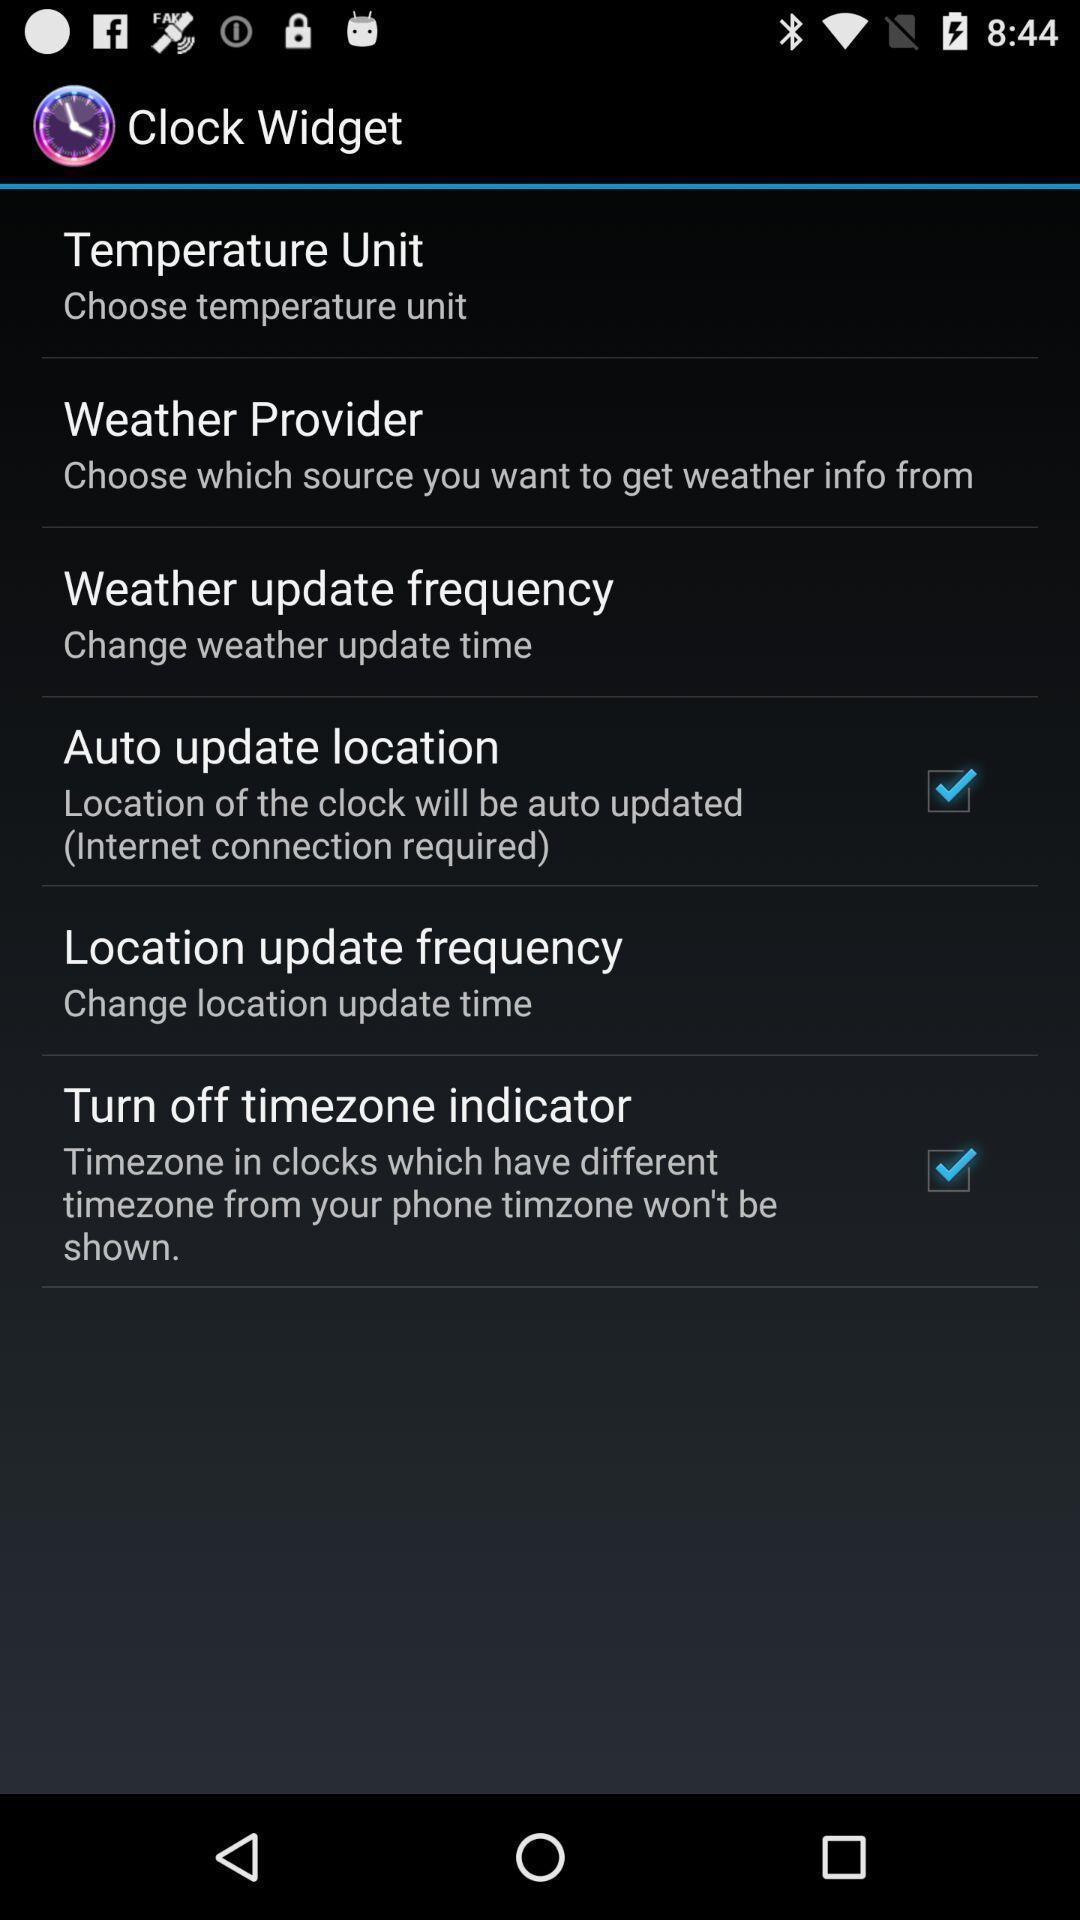Describe this image in words. Settings page. 